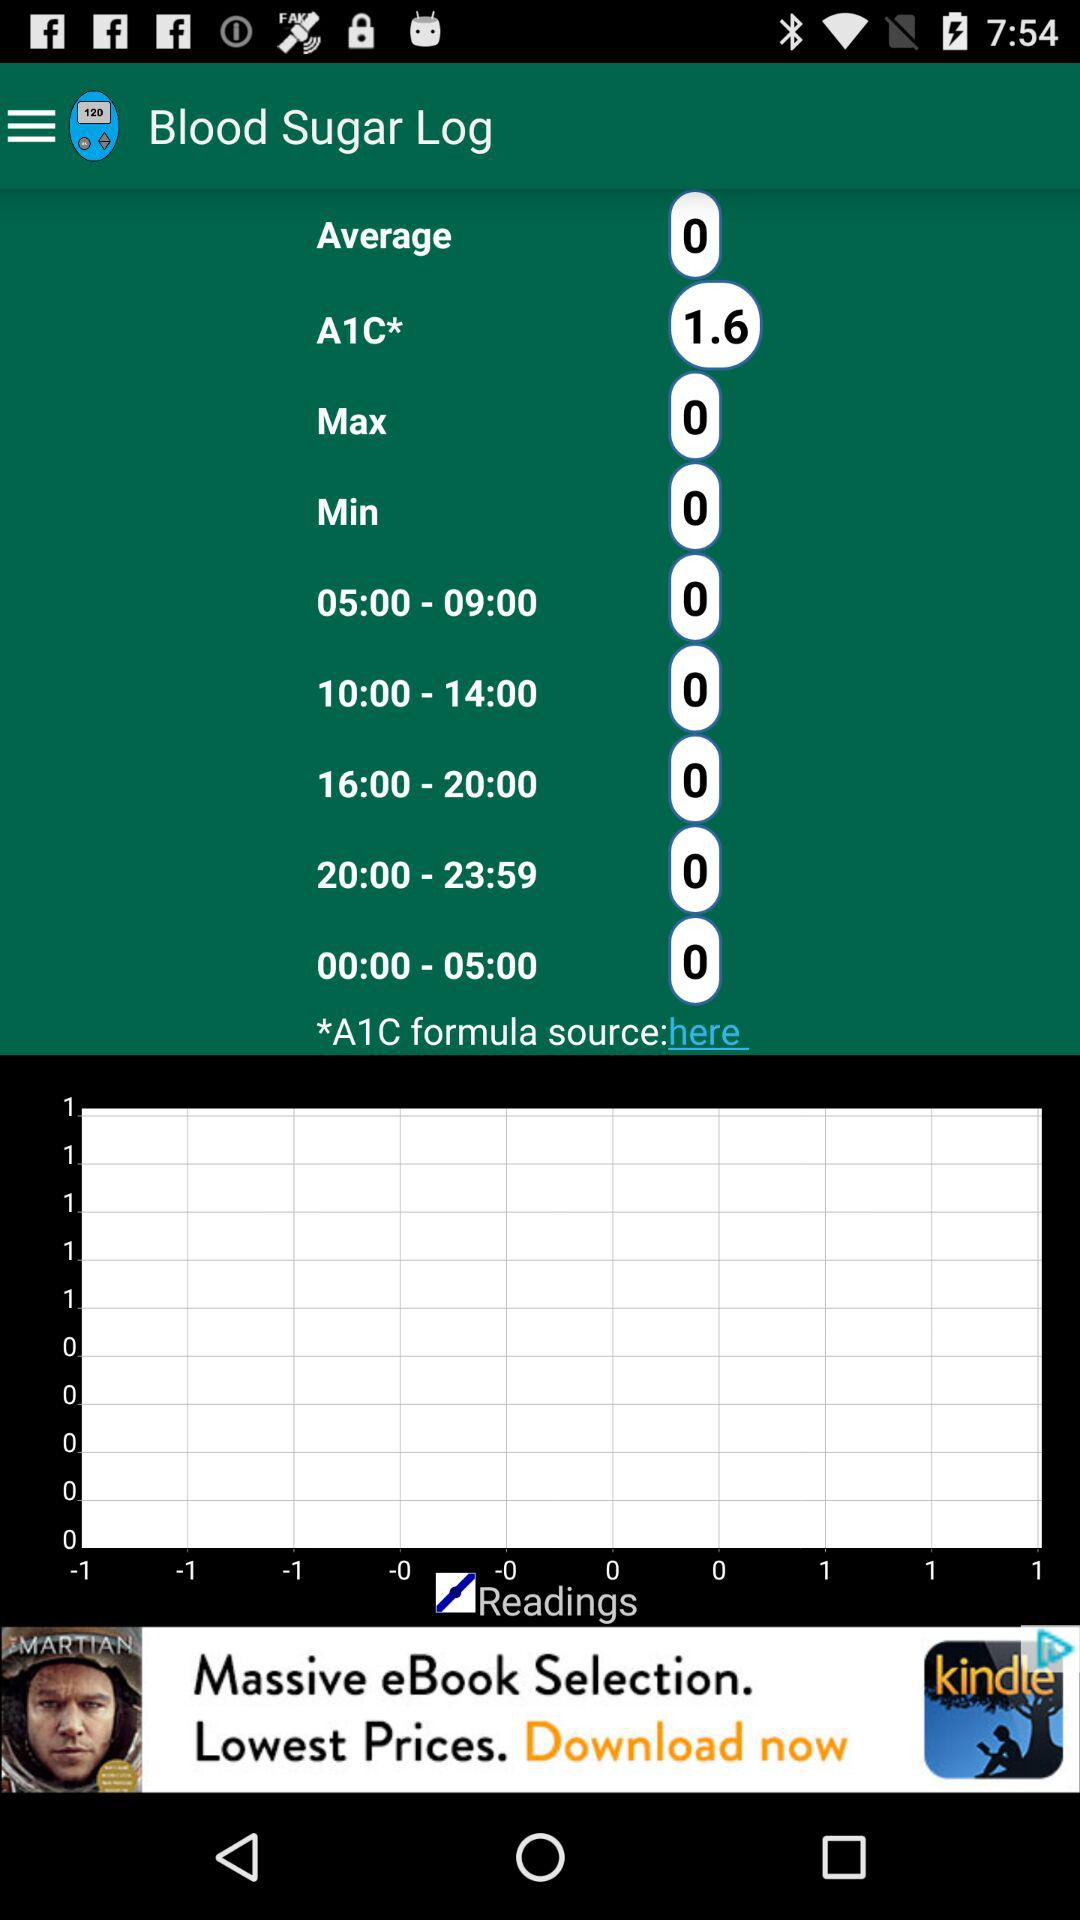What is the application name? The application name is "Blood Sugar Log". 